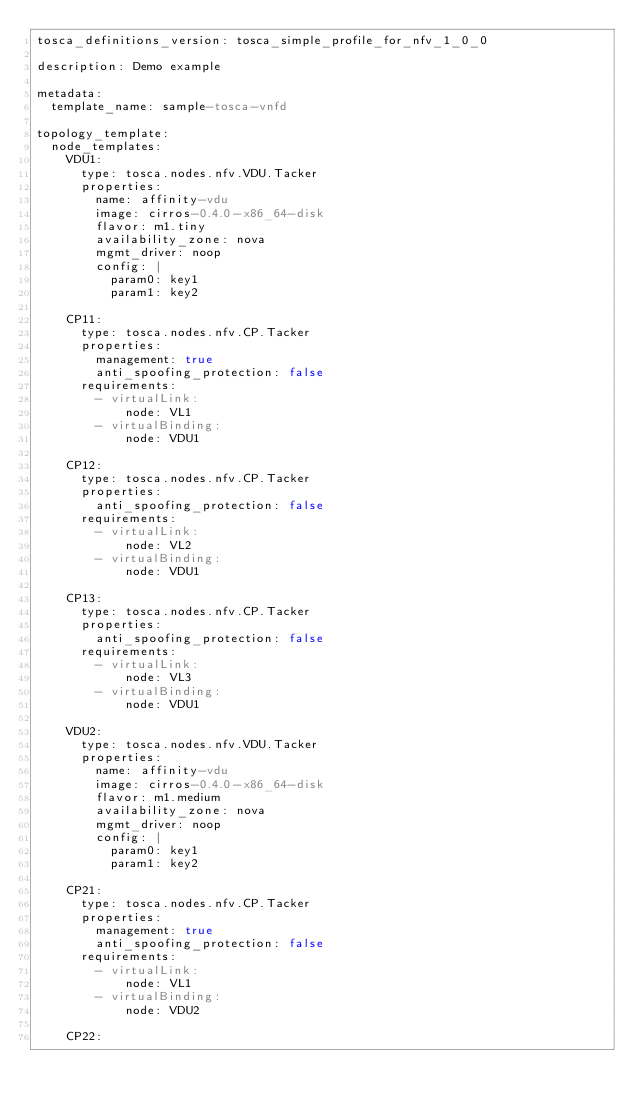Convert code to text. <code><loc_0><loc_0><loc_500><loc_500><_YAML_>tosca_definitions_version: tosca_simple_profile_for_nfv_1_0_0

description: Demo example

metadata:
  template_name: sample-tosca-vnfd

topology_template:
  node_templates:
    VDU1:
      type: tosca.nodes.nfv.VDU.Tacker
      properties:
        name: affinity-vdu
        image: cirros-0.4.0-x86_64-disk
        flavor: m1.tiny
        availability_zone: nova
        mgmt_driver: noop
        config: |
          param0: key1
          param1: key2

    CP11:
      type: tosca.nodes.nfv.CP.Tacker
      properties:
        management: true
        anti_spoofing_protection: false
      requirements:
        - virtualLink:
            node: VL1
        - virtualBinding:
            node: VDU1

    CP12:
      type: tosca.nodes.nfv.CP.Tacker
      properties:
        anti_spoofing_protection: false
      requirements:
        - virtualLink:
            node: VL2
        - virtualBinding:
            node: VDU1

    CP13:
      type: tosca.nodes.nfv.CP.Tacker
      properties:
        anti_spoofing_protection: false
      requirements:
        - virtualLink:
            node: VL3
        - virtualBinding:
            node: VDU1

    VDU2:
      type: tosca.nodes.nfv.VDU.Tacker
      properties:
        name: affinity-vdu
        image: cirros-0.4.0-x86_64-disk
        flavor: m1.medium
        availability_zone: nova
        mgmt_driver: noop
        config: |
          param0: key1
          param1: key2

    CP21:
      type: tosca.nodes.nfv.CP.Tacker
      properties:
        management: true
        anti_spoofing_protection: false
      requirements:
        - virtualLink:
            node: VL1
        - virtualBinding:
            node: VDU2

    CP22:</code> 